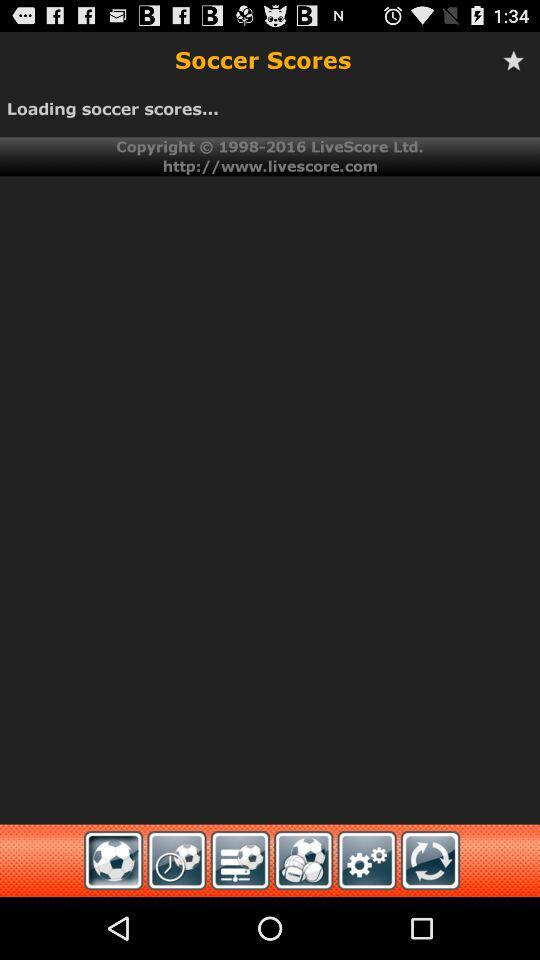What is the name of the application? The name of the application is "Soccer Scores". 